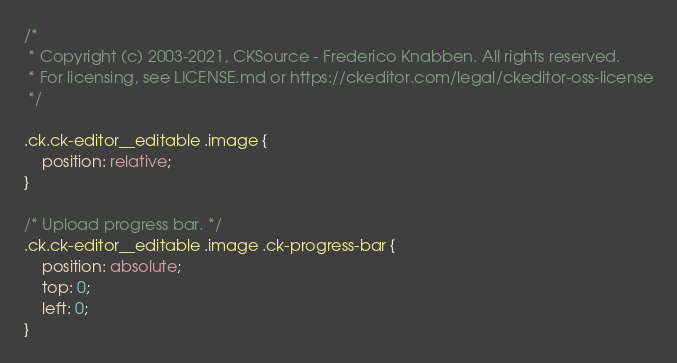Convert code to text. <code><loc_0><loc_0><loc_500><loc_500><_CSS_>/*
 * Copyright (c) 2003-2021, CKSource - Frederico Knabben. All rights reserved.
 * For licensing, see LICENSE.md or https://ckeditor.com/legal/ckeditor-oss-license
 */

.ck.ck-editor__editable .image {
	position: relative;
}

/* Upload progress bar. */
.ck.ck-editor__editable .image .ck-progress-bar {
	position: absolute;
	top: 0;
	left: 0;
}
</code> 